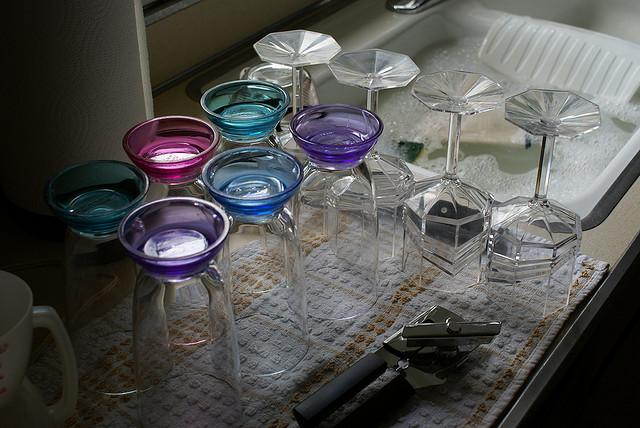Why are the glasses on a rag next to the sink? Please explain your reasoning. just washed. They are there to dry off 